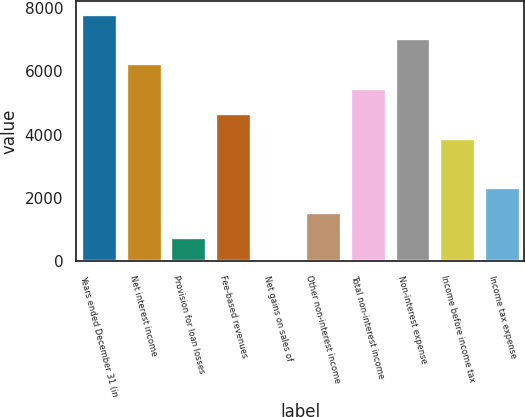Convert chart to OTSL. <chart><loc_0><loc_0><loc_500><loc_500><bar_chart><fcel>Years ended December 31 (in<fcel>Net interest income<fcel>Provision for loan losses<fcel>Fee-based revenues<fcel>Net gains on sales of<fcel>Other non-interest income<fcel>Total non-interest income<fcel>Non-interest expense<fcel>Income before income tax<fcel>Income tax expense<nl><fcel>7807.8<fcel>6246.64<fcel>782.58<fcel>4685.48<fcel>2<fcel>1563.16<fcel>5466.06<fcel>7027.22<fcel>3904.9<fcel>2343.74<nl></chart> 